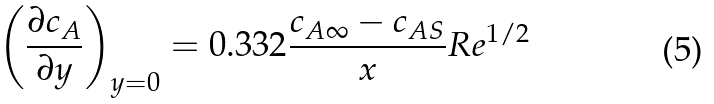Convert formula to latex. <formula><loc_0><loc_0><loc_500><loc_500>\left ( { \frac { \partial c _ { A } } { \partial y } } \right ) _ { y = 0 } = 0 . 3 3 2 { \frac { c _ { A \infty } - c _ { A S } } { x } } R e ^ { 1 / 2 }</formula> 